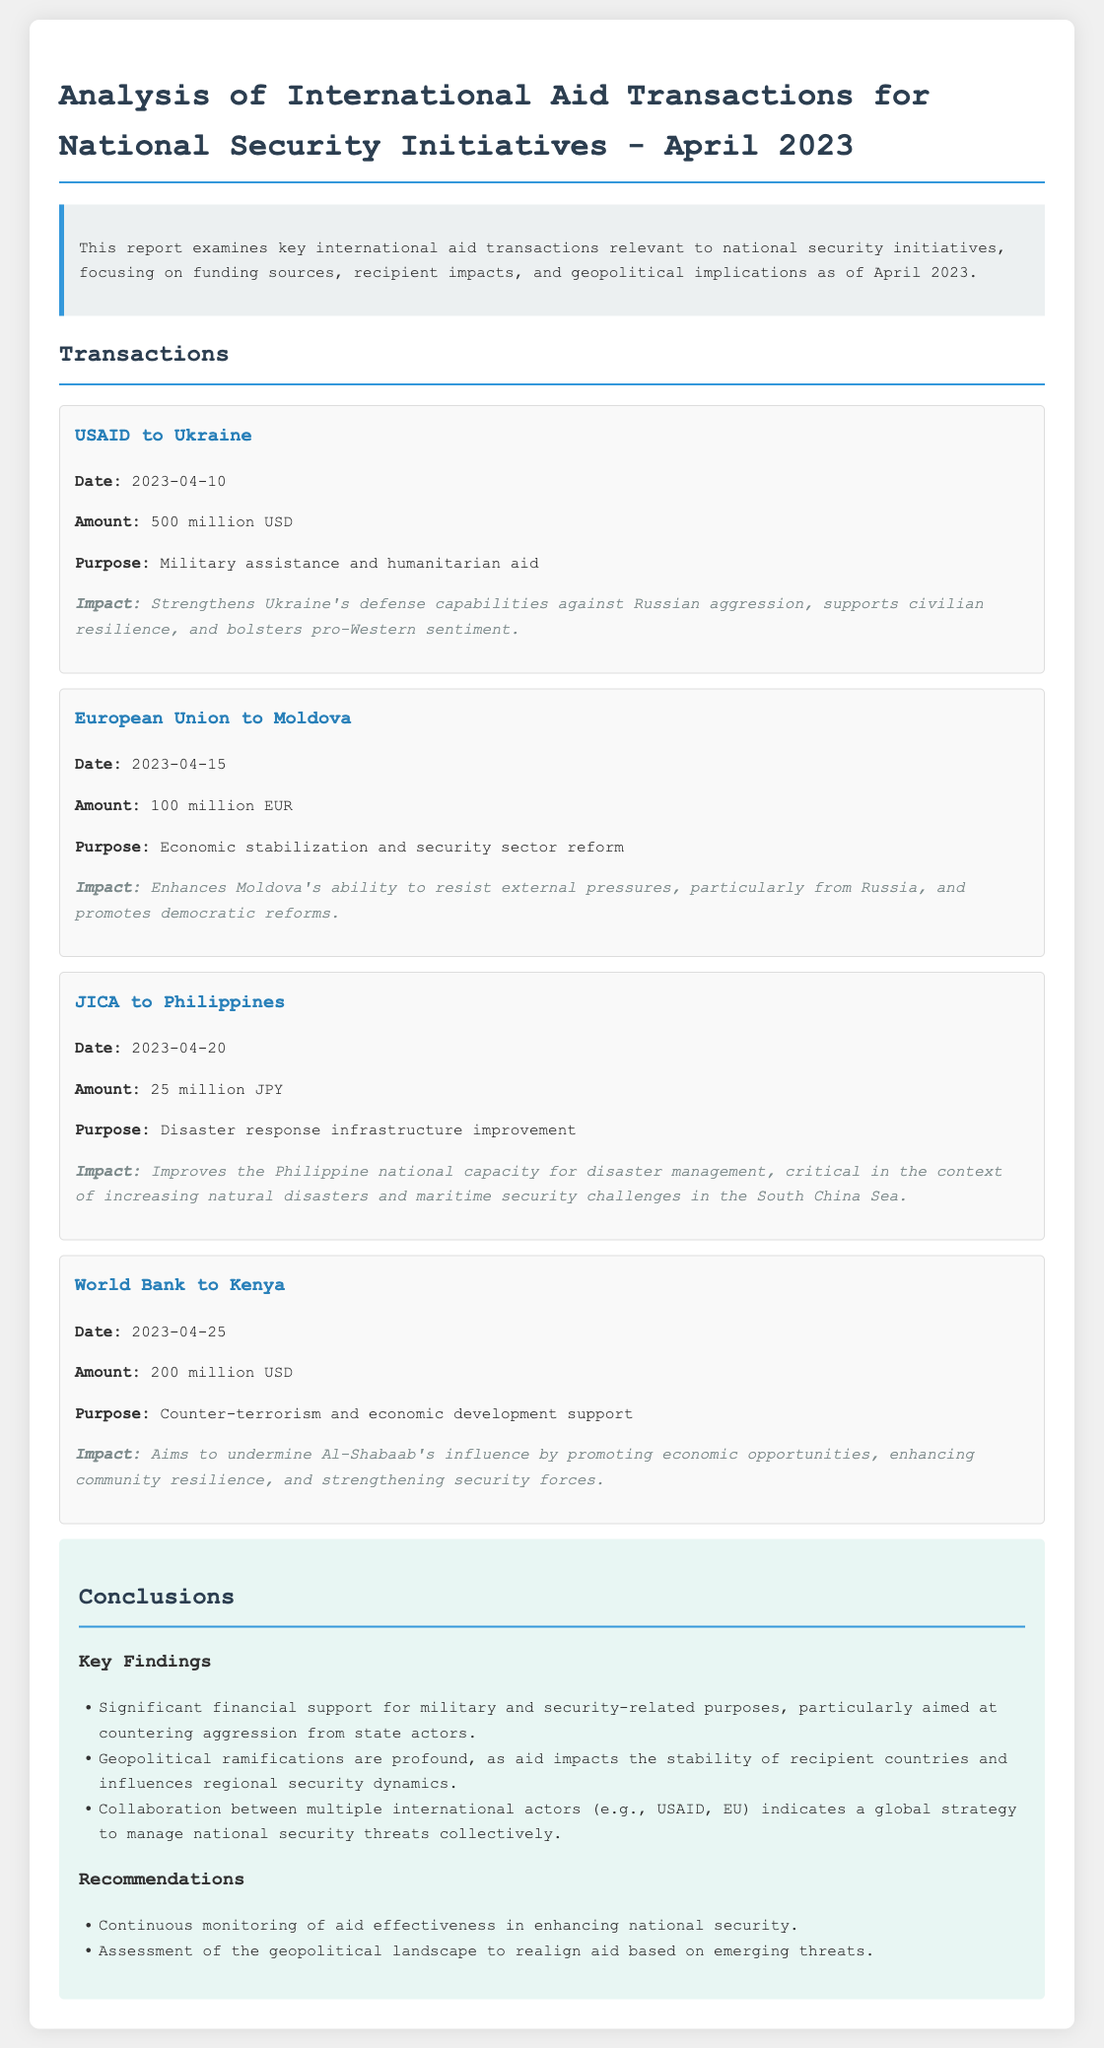What amount did USAID allocate to Ukraine? The document specifies the amount allocated by USAID to Ukraine as 500 million USD.
Answer: 500 million USD What was the purpose of the European Union's aid to Moldova? The document states that the purpose of the aid from the European Union to Moldova was economic stabilization and security sector reform.
Answer: Economic stabilization and security sector reform What is the date of the transaction from JICA to the Philippines? According to the document, the transaction from JICA to the Philippines occurred on 2023-04-20.
Answer: 2023-04-20 What was the total amount of aid to Kenya from the World Bank? The document indicates that the World Bank provided 200 million USD to Kenya.
Answer: 200 million USD What impact is aimed at undermining Al-Shabaab's influence? The document describes the impact of the World Bank's aid to Kenya as promoting economic opportunities and enhancing community resilience to undermine Al-Shabaab's influence.
Answer: Promoting economic opportunities What are the significant financial supports mentioned? The document highlights significant financial support for military and security-related purposes, particularly aimed at countering aggression from state actors.
Answer: Military and security-related purposes What underlying reason is suggested for collaboration between international actors? The document indicates that the collaboration reflects a global strategy to manage national security threats collectively.
Answer: A global strategy to manage national security threats What is the purpose of the aid provided by JICA to the Philippines? The document states that the purpose of the aid from JICA to the Philippines is disaster response infrastructure improvement.
Answer: Disaster response infrastructure improvement 